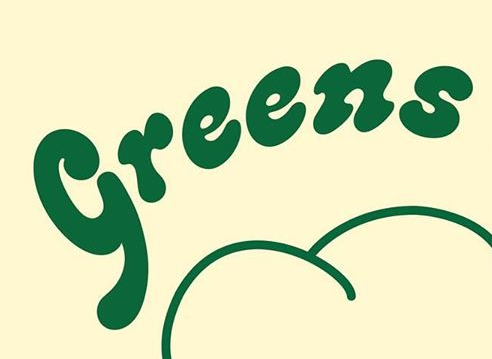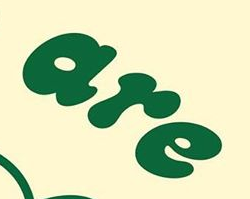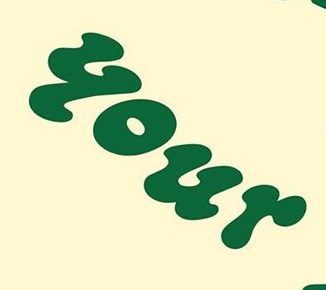What text appears in these images from left to right, separated by a semicolon? Greens; are; your 